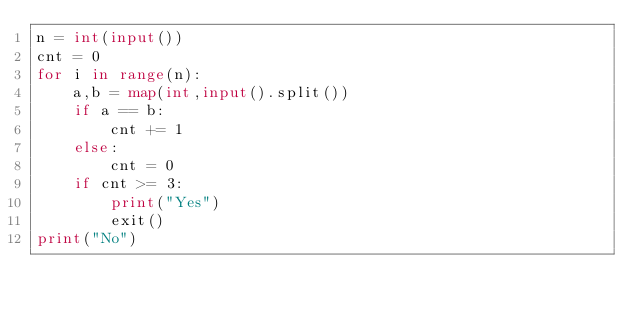<code> <loc_0><loc_0><loc_500><loc_500><_Python_>n = int(input())
cnt = 0
for i in range(n):
    a,b = map(int,input().split())
    if a == b:
        cnt += 1
    else:
        cnt = 0
    if cnt >= 3:
        print("Yes")
        exit()
print("No")</code> 